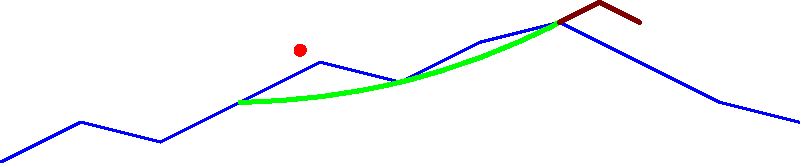As a project coordinator for a geological sciences research team, you're reviewing a simplified landscape diagram showing glacial features. Identify the glacial landforms labeled A, B, and C in the diagram. To identify the glacial features in the diagram, let's analyze each labeled element:

1. Feature A: This is a U-shaped valley, characterized by its broad, curved shape. U-shaped valleys are formed by glacial erosion as ice moves downslope, carving out the sides and bottom of pre-existing V-shaped valleys.

2. Feature B: This is a moraine, a ridge-like accumulation of glacial debris (rock and sediment) deposited by a glacier. Moraines can form at the sides, front, or middle of a glacier and remain after the ice has melted.

3. Feature C: This is an erratic, a large rock that has been transported by glacial ice and deposited in a location with a different underlying rock type. Erratics can range from pebble-sized to house-sized boulders.

These features are common indicators of past glacial activity in a landscape. As a project coordinator, recognizing these features is crucial for understanding the geological history of an area and planning research activities accordingly.
Answer: A: U-shaped valley, B: Moraine, C: Erratic 